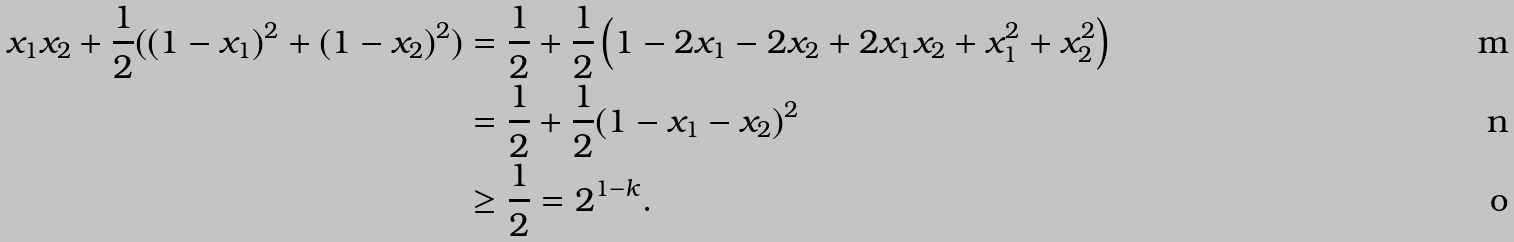<formula> <loc_0><loc_0><loc_500><loc_500>x _ { 1 } x _ { 2 } + \frac { 1 } { 2 } ( { ( 1 - x _ { 1 } ) ^ { 2 } + ( 1 - x _ { 2 } ) ^ { 2 } } ) & = \frac { 1 } { 2 } + \frac { 1 } { 2 } \left ( 1 - 2 x _ { 1 } - 2 x _ { 2 } + 2 x _ { 1 } x _ { 2 } + x _ { 1 } ^ { 2 } + x _ { 2 } ^ { 2 } \right ) \\ & = \frac { 1 } { 2 } + \frac { 1 } { 2 } ( 1 - x _ { 1 } - x _ { 2 } ) ^ { 2 } \\ & \geq \frac { 1 } { 2 } = 2 ^ { 1 - k } .</formula> 